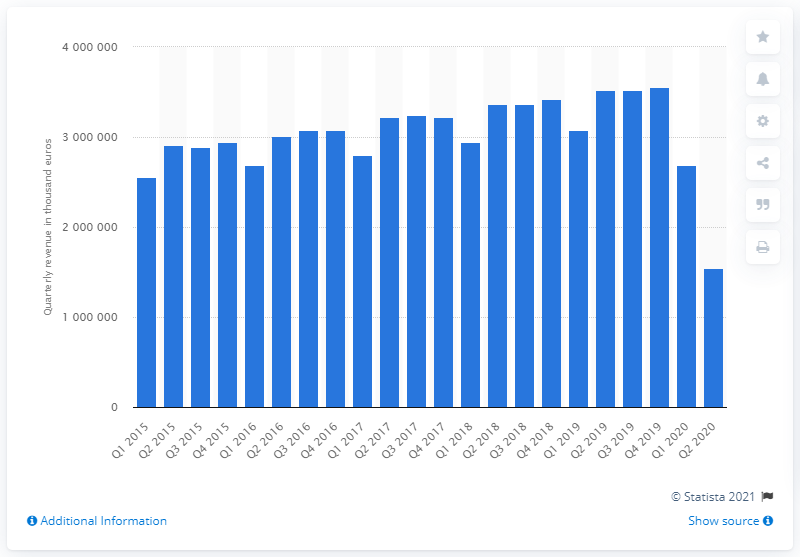Specify some key components in this picture. The revenue for the restaurant industry in the second quarter of 2015 was approximately 288,800,111. 